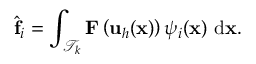<formula> <loc_0><loc_0><loc_500><loc_500>\hat { f } _ { i } = \int _ { \mathcal { T } _ { k } } F \left ( u _ { h } ( x ) \right ) { \psi } _ { i } ( x ) \ d x .</formula> 